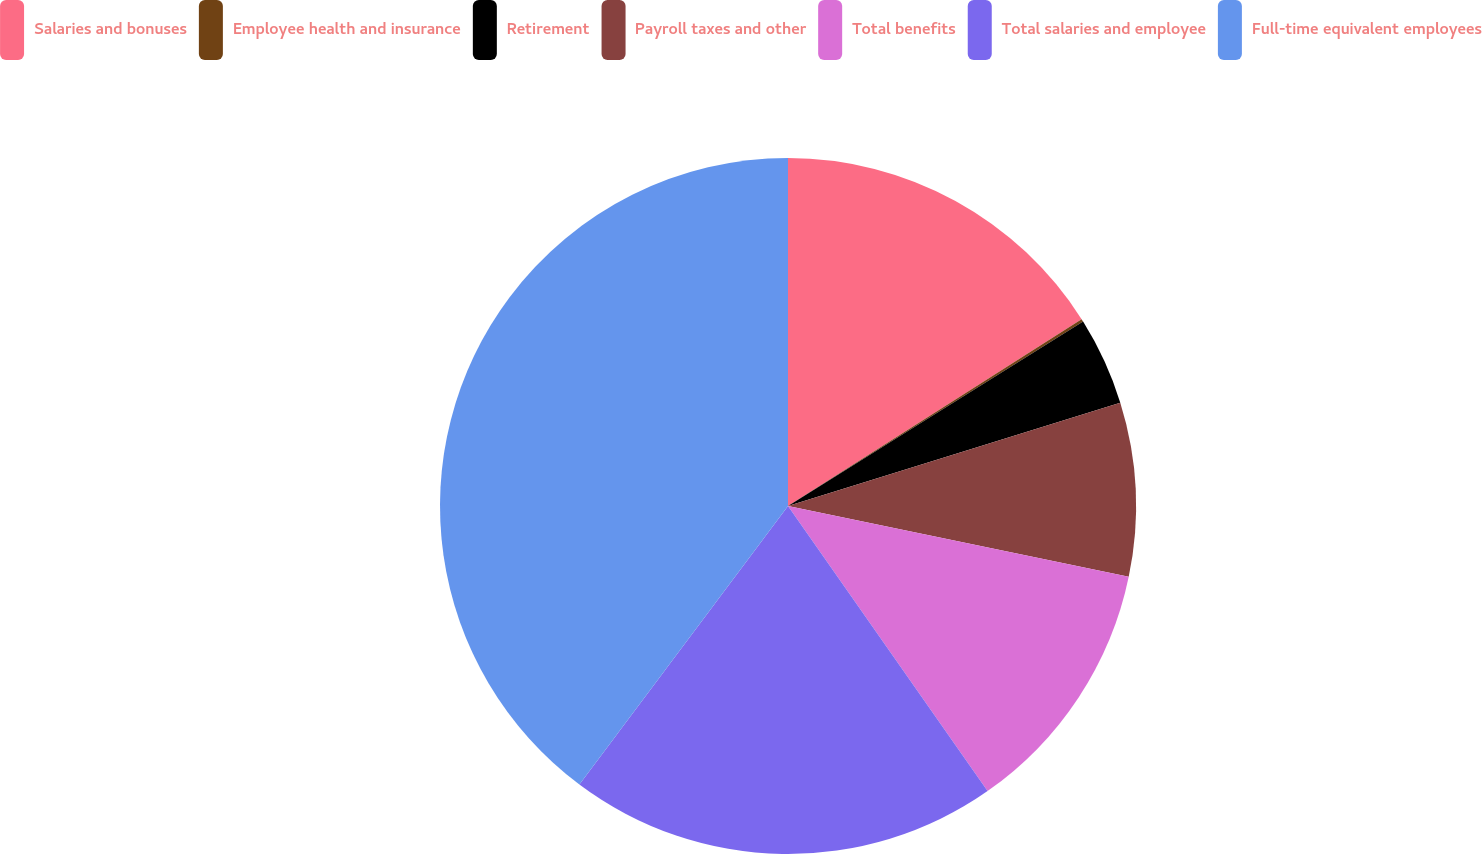Convert chart to OTSL. <chart><loc_0><loc_0><loc_500><loc_500><pie_chart><fcel>Salaries and bonuses<fcel>Employee health and insurance<fcel>Retirement<fcel>Payroll taxes and other<fcel>Total benefits<fcel>Total salaries and employee<fcel>Full-time equivalent employees<nl><fcel>15.98%<fcel>0.13%<fcel>4.09%<fcel>8.06%<fcel>12.02%<fcel>19.95%<fcel>39.77%<nl></chart> 